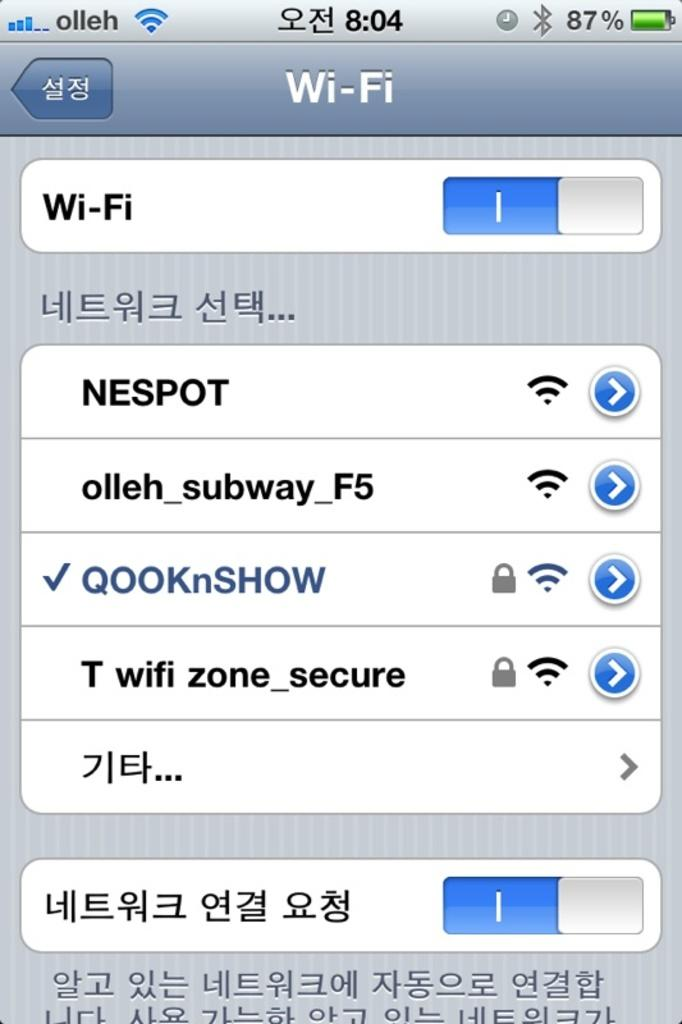<image>
Provide a brief description of the given image. A phone with three bars displaying that it is wi-fi connected with 87% battery life remaining. 